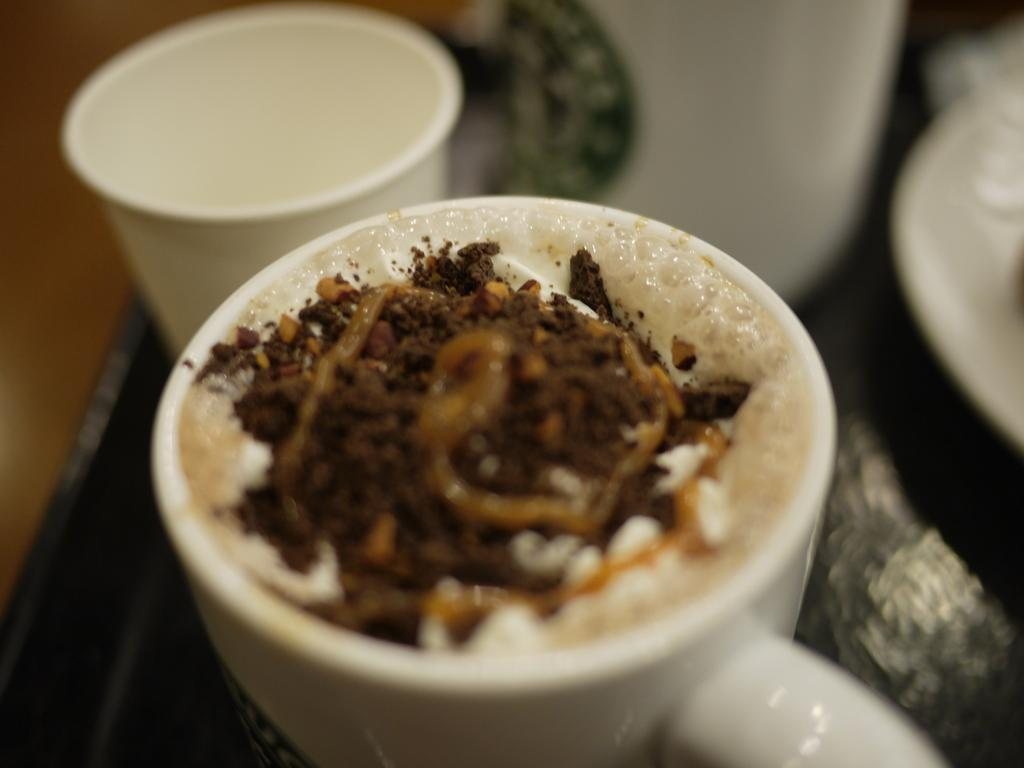What objects are on the table in the image? There are cups on a table in the image. What is inside the cups? There is a drink in at least one of the cups. Can you see a squirrel helping the mom in the image? There is no squirrel or mom present in the image. 